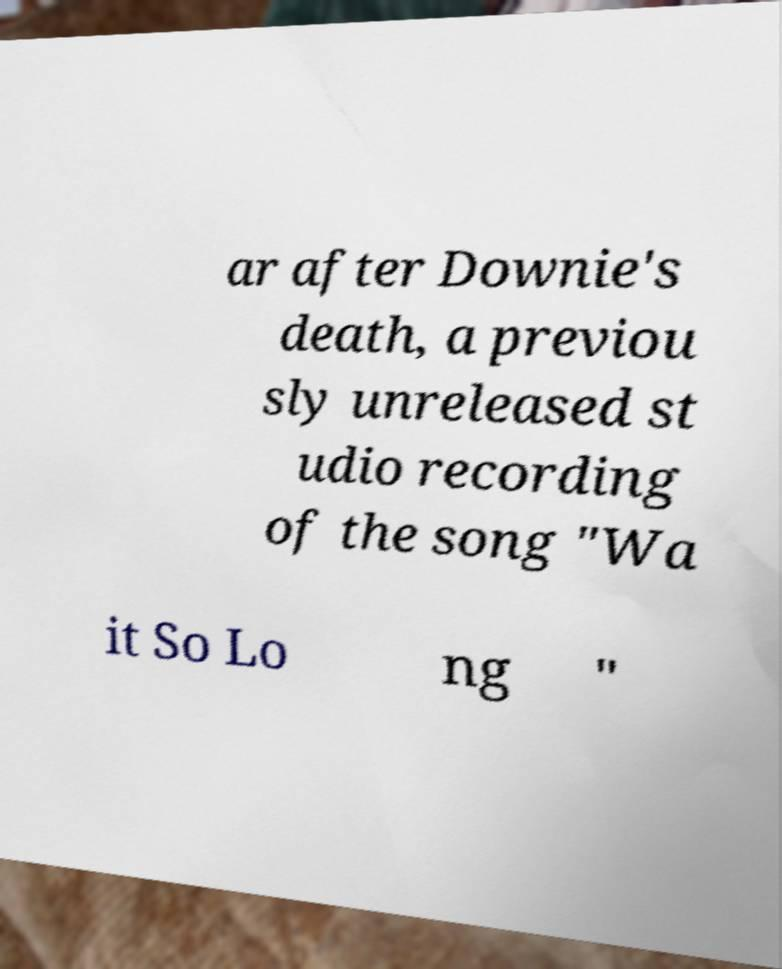Can you accurately transcribe the text from the provided image for me? ar after Downie's death, a previou sly unreleased st udio recording of the song "Wa it So Lo ng " 